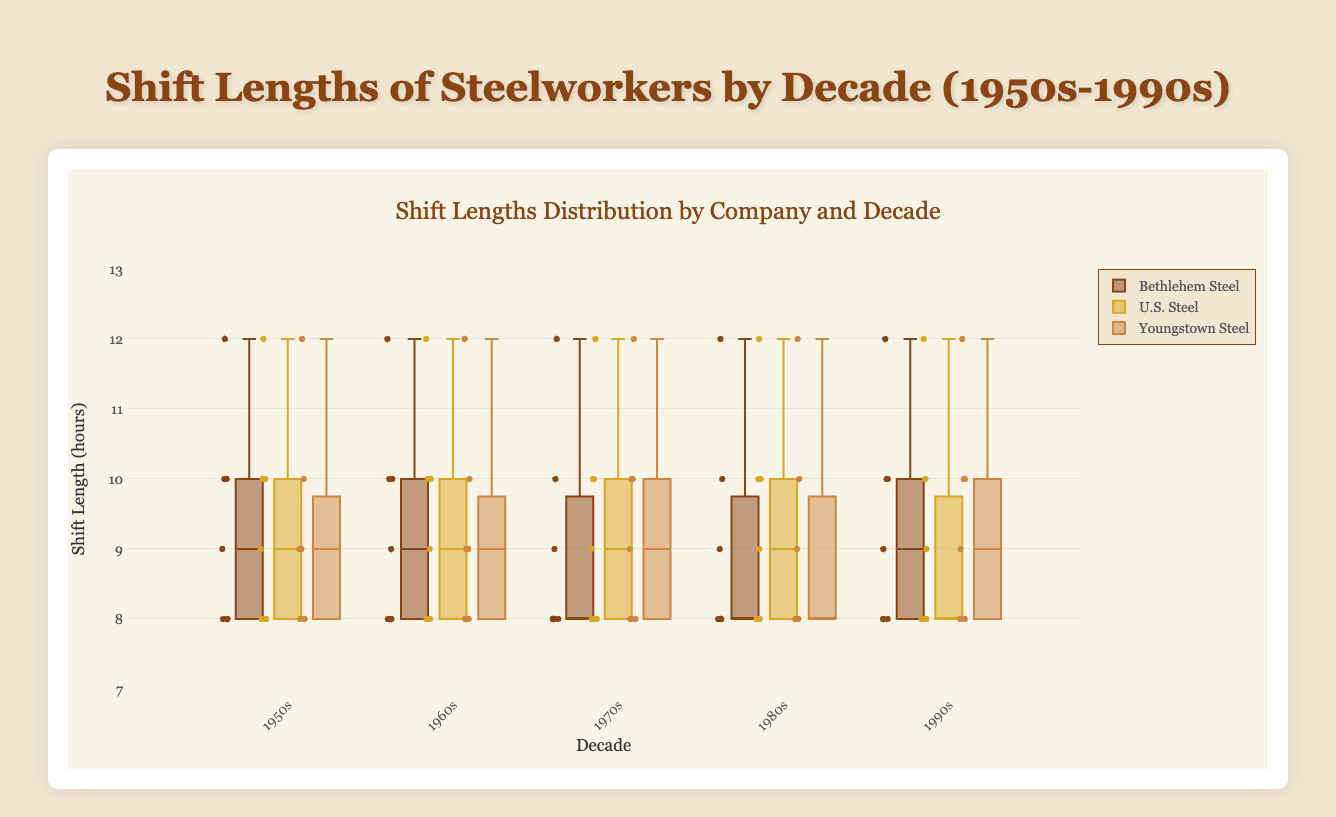What is the range of shift lengths for Bethlehem Steel in the 1950s? The range is the difference between the maximum and minimum values. For Bethlehem Steel in the 1950s, the shift lengths range from 8 to 12 hours, so the range is 12 - 8 = 4.
Answer: 4 Which company had the highest median shift length in the 1960s? The median shift length for each company can be estimated by looking at the middle line in each box of the box plot for the 1960s. Both 'U.S. Steel' and 'Youngstown Steel' have medians close to 9 or 10, with 'Youngstown Steel' slightly higher.
Answer: Youngstown Steel How does the shift length variability for 'U.S. Steel' in the 1970s compare to that in the 1990s? Variability can be assessed by looking at the spread or interquartile range (IQR) of the shift lengths. For 'U.S. Steel', the 1970s plot appears more spread out compared to the 1990s, indicating higher variability in the 1970s.
Answer: 1970s What decade shows the least variability in shift lengths for Bethlehem Steel? Least variability implies the smallest interquartile range (IQR). For Bethlehem Steel, the decade with the least spread between the first and third quartiles appears to be the 1970s.
Answer: 1970s Which decade had the longest typical shift lengths for Youngstown Steel? To find the decade with the longest typical shift lengths, identify the decade where the median shift length (middle line in the box) for Youngstown Steel is the highest. This appears to be the 1990s.
Answer: 1990s What is the interquartile range (IQR) for U.S. Steel shift lengths in the 1980s? The IQR is the difference between the third quartile (Q3) and the first quartile (Q1). For U.S. Steel in the 1980s, Q1 is approximately 8 and Q3 is approximately 10. The IQR is 10 - 8 = 2.
Answer: 2 Were there any outliers in shift lengths for Bethlehem Steel in the 1990s? Outliers in a box plot are often represented as dots beyond the whiskers. By visually inspecting the box plot for Bethlehem Steel in the 1990s, no outliers appear to be present.
Answer: No 